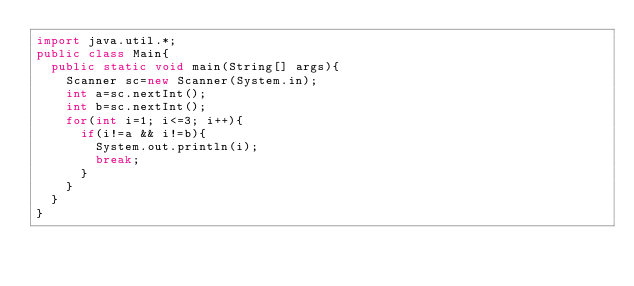Convert code to text. <code><loc_0><loc_0><loc_500><loc_500><_Java_>import java.util.*;
public class Main{
	public static void main(String[] args){
		Scanner sc=new Scanner(System.in);
		int a=sc.nextInt();
		int b=sc.nextInt();
		for(int i=1; i<=3; i++){
			if(i!=a && i!=b){
				System.out.println(i);
				break;
			}
		}
	}
}
</code> 